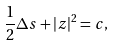<formula> <loc_0><loc_0><loc_500><loc_500>\frac { 1 } { 2 } \Delta s + | z | ^ { 2 } = c ,</formula> 